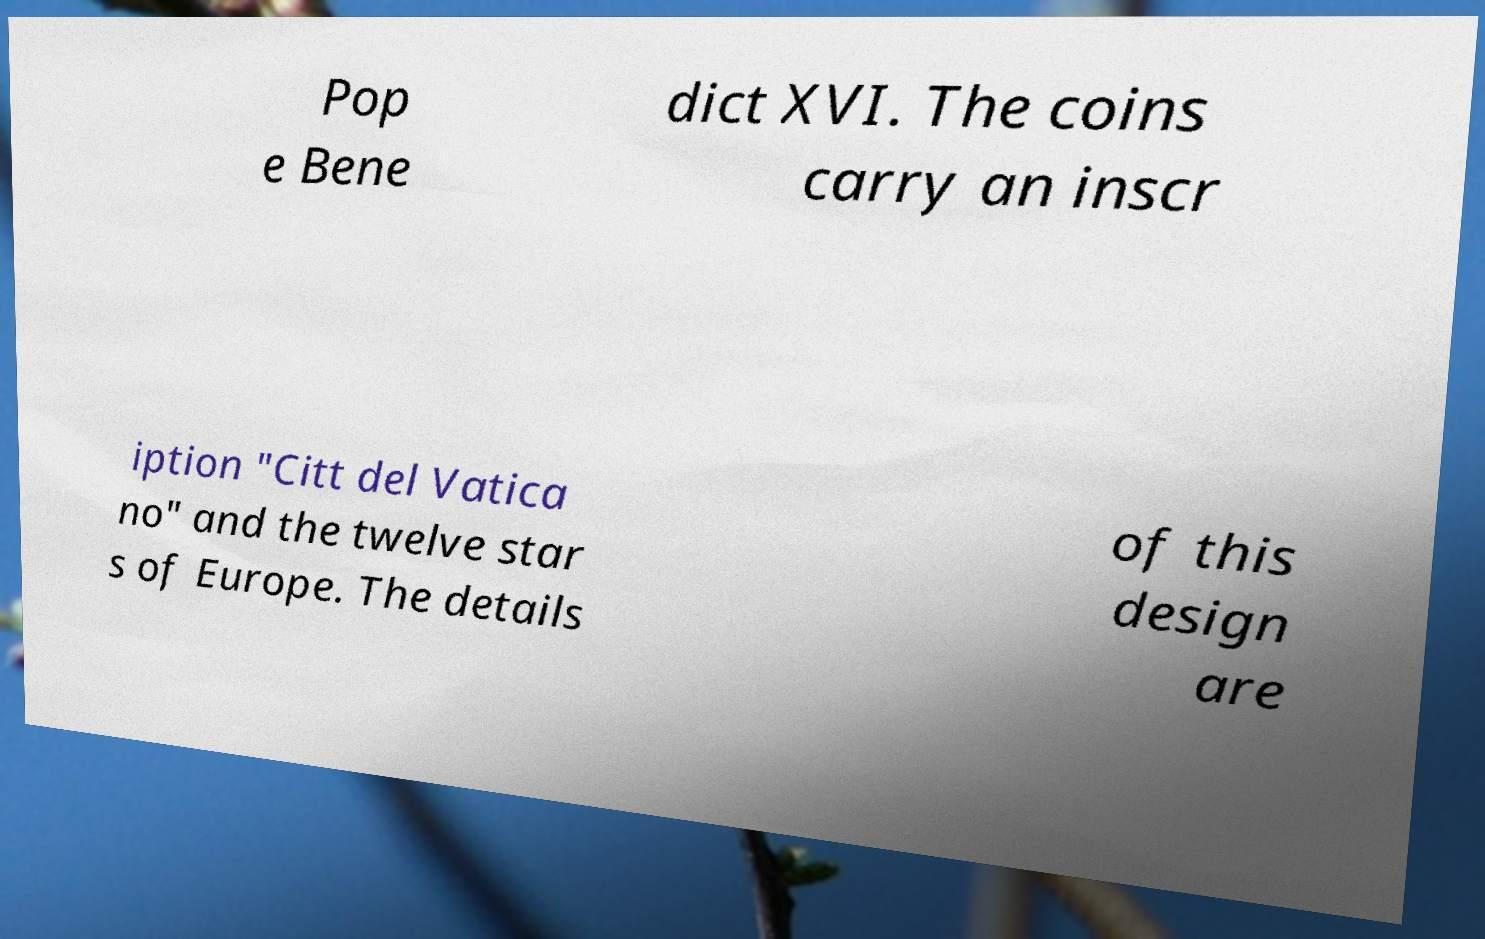Could you assist in decoding the text presented in this image and type it out clearly? Pop e Bene dict XVI. The coins carry an inscr iption "Citt del Vatica no" and the twelve star s of Europe. The details of this design are 